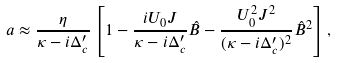Convert formula to latex. <formula><loc_0><loc_0><loc_500><loc_500>a \approx \frac { \eta } { \kappa - i \Delta ^ { \prime } _ { c } } \left [ 1 - \frac { i U _ { 0 } J } { \kappa - i \Delta ^ { \prime } _ { c } } \hat { B } - \frac { U _ { 0 } ^ { 2 } J ^ { 2 } } { ( \kappa - i \Delta ^ { \prime } _ { c } ) ^ { 2 } } \hat { B } ^ { 2 } \right ] ,</formula> 